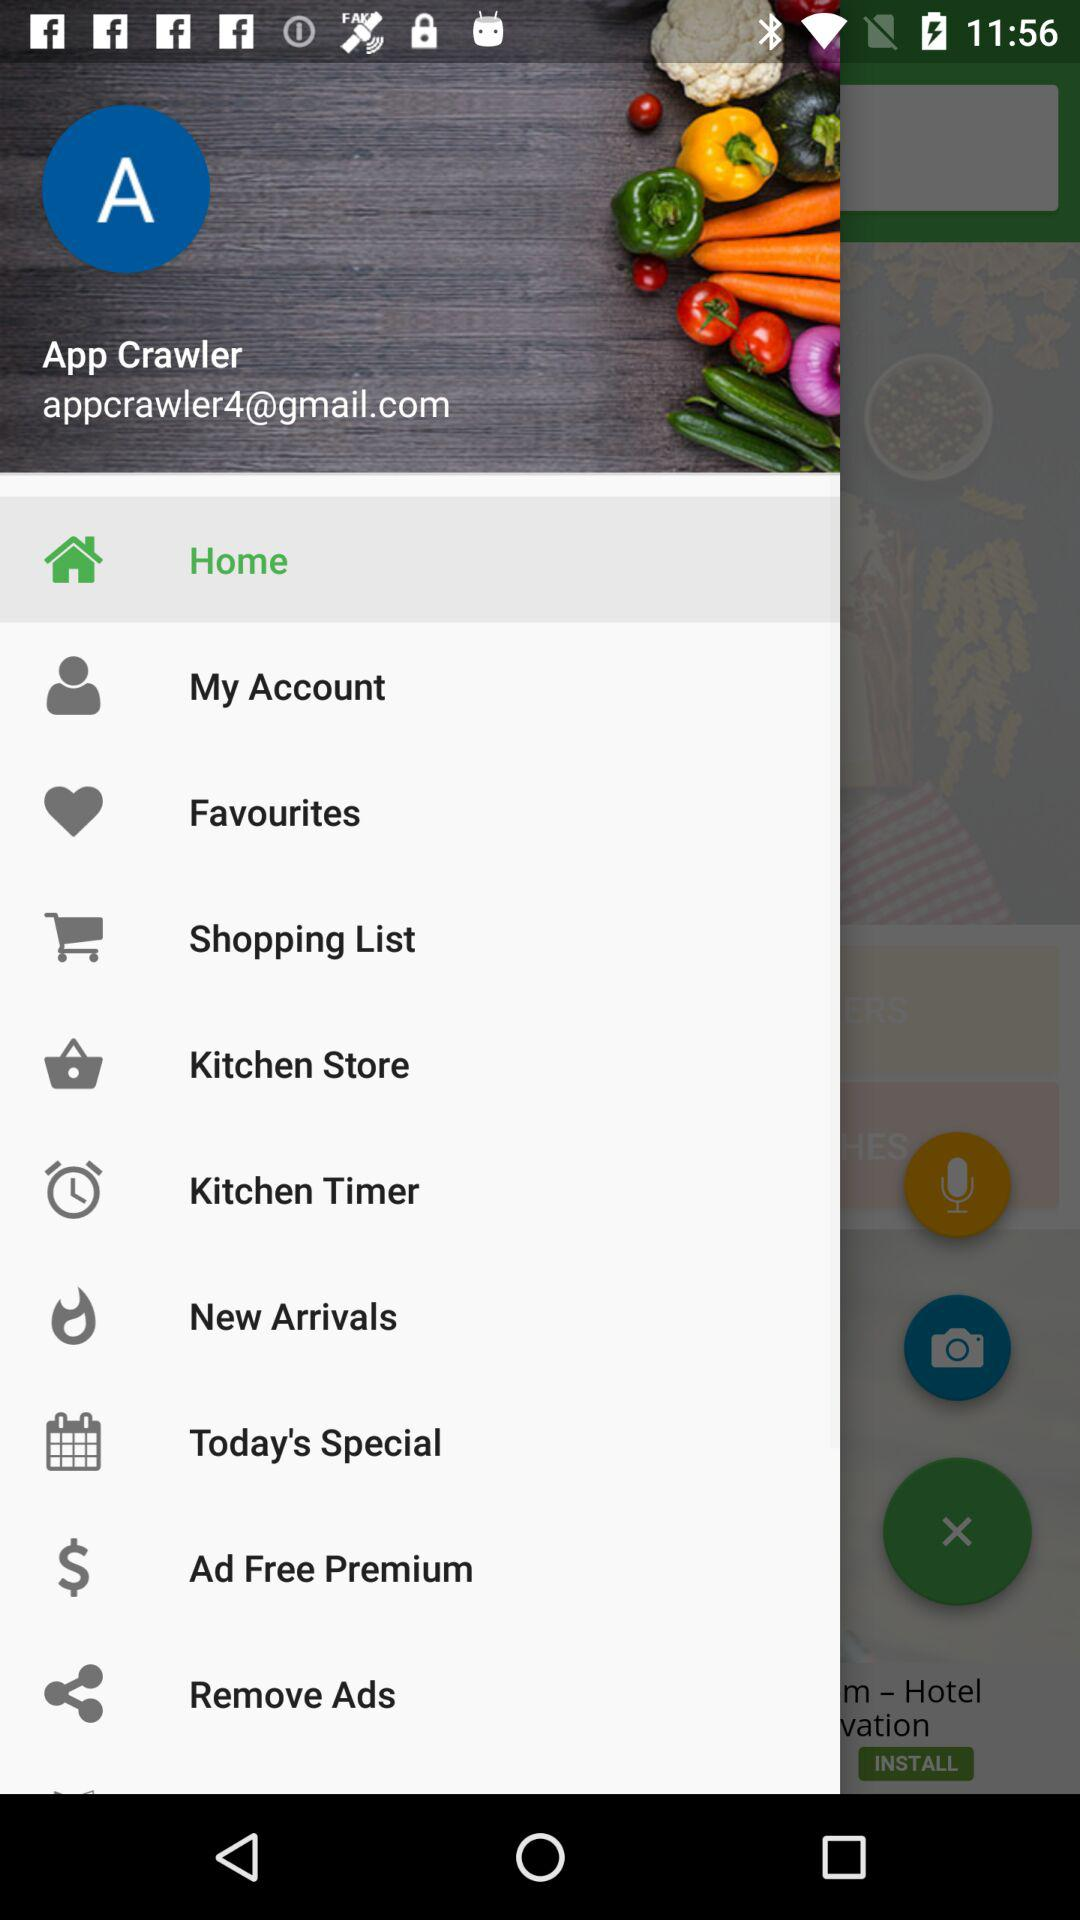What is the email address? The email address is appcrawler4@gmail.com. 